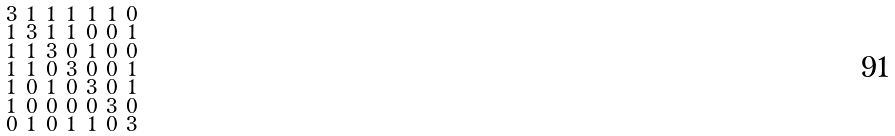<formula> <loc_0><loc_0><loc_500><loc_500>\begin{smallmatrix} 3 & 1 & 1 & 1 & 1 & 1 & 0 \\ 1 & 3 & 1 & 1 & 0 & 0 & 1 \\ 1 & 1 & 3 & 0 & 1 & 0 & 0 \\ 1 & 1 & 0 & 3 & 0 & 0 & 1 \\ 1 & 0 & 1 & 0 & 3 & 0 & 1 \\ 1 & 0 & 0 & 0 & 0 & 3 & 0 \\ 0 & 1 & 0 & 1 & 1 & 0 & 3 \end{smallmatrix}</formula> 